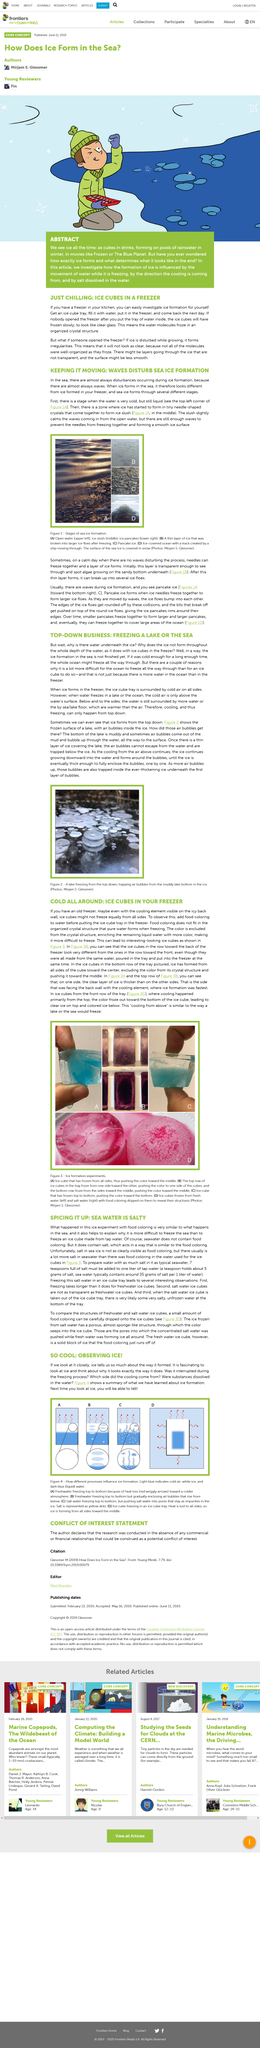Specify some key components in this picture. The image depicts a lake that is freezing from the top down, revealing the ice crystals that form in the water. The above picture portrays the results of ice formation experiments. Ice forms in a freezer when the ice cube tray is surrounded by cold air from all sides, as it is in the freezer compartment of a refrigerator. It is a universal truth that waves are almost always present in the sea. Yes, sea ice forms through several different stages. 